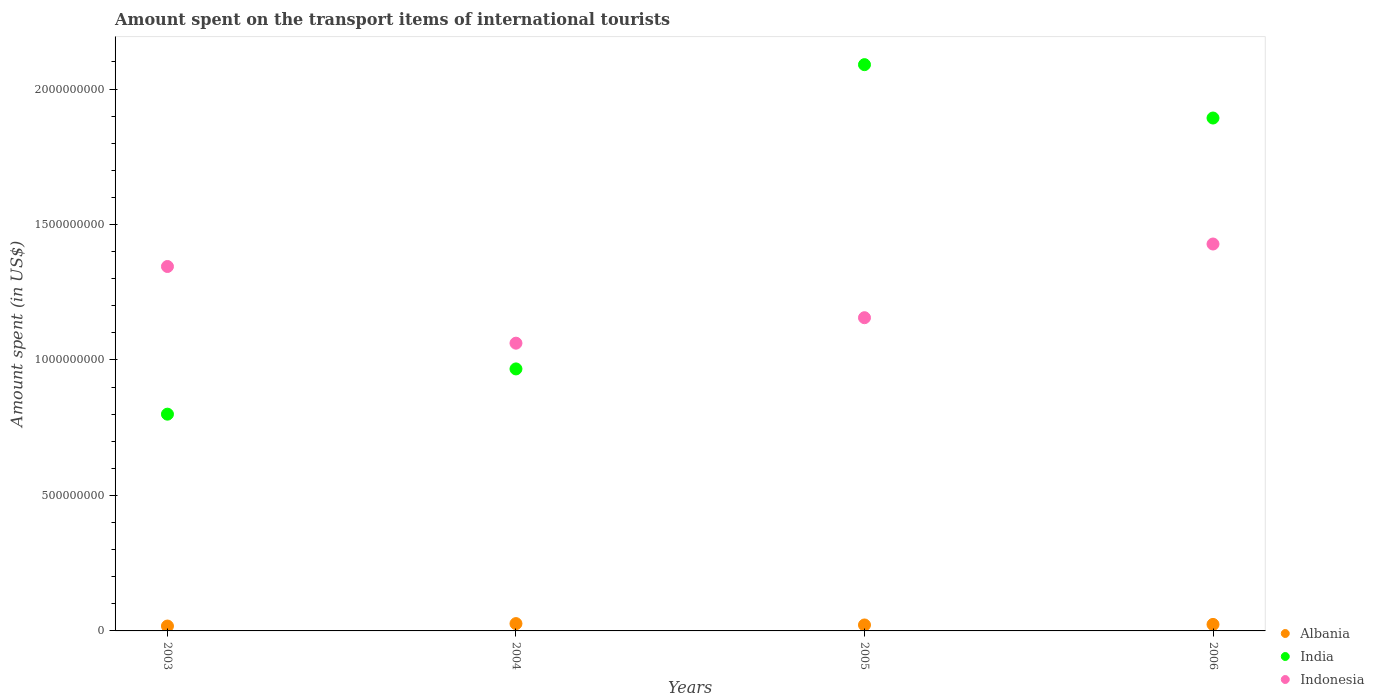How many different coloured dotlines are there?
Your response must be concise. 3. What is the amount spent on the transport items of international tourists in Indonesia in 2006?
Provide a succinct answer. 1.43e+09. Across all years, what is the maximum amount spent on the transport items of international tourists in India?
Provide a short and direct response. 2.09e+09. Across all years, what is the minimum amount spent on the transport items of international tourists in Albania?
Offer a terse response. 1.80e+07. In which year was the amount spent on the transport items of international tourists in Albania minimum?
Your answer should be very brief. 2003. What is the total amount spent on the transport items of international tourists in Indonesia in the graph?
Offer a very short reply. 4.99e+09. What is the difference between the amount spent on the transport items of international tourists in Albania in 2003 and that in 2004?
Your answer should be very brief. -9.00e+06. What is the difference between the amount spent on the transport items of international tourists in India in 2003 and the amount spent on the transport items of international tourists in Albania in 2005?
Ensure brevity in your answer.  7.78e+08. What is the average amount spent on the transport items of international tourists in Indonesia per year?
Your response must be concise. 1.25e+09. In the year 2003, what is the difference between the amount spent on the transport items of international tourists in Indonesia and amount spent on the transport items of international tourists in India?
Provide a succinct answer. 5.45e+08. What is the ratio of the amount spent on the transport items of international tourists in Albania in 2003 to that in 2006?
Offer a very short reply. 0.75. Is the amount spent on the transport items of international tourists in Indonesia in 2005 less than that in 2006?
Keep it short and to the point. Yes. What is the difference between the highest and the second highest amount spent on the transport items of international tourists in Indonesia?
Make the answer very short. 8.30e+07. What is the difference between the highest and the lowest amount spent on the transport items of international tourists in Indonesia?
Your answer should be compact. 3.66e+08. In how many years, is the amount spent on the transport items of international tourists in Albania greater than the average amount spent on the transport items of international tourists in Albania taken over all years?
Give a very brief answer. 2. Is the sum of the amount spent on the transport items of international tourists in India in 2003 and 2006 greater than the maximum amount spent on the transport items of international tourists in Albania across all years?
Provide a succinct answer. Yes. Is it the case that in every year, the sum of the amount spent on the transport items of international tourists in Albania and amount spent on the transport items of international tourists in India  is greater than the amount spent on the transport items of international tourists in Indonesia?
Provide a succinct answer. No. Does the amount spent on the transport items of international tourists in Albania monotonically increase over the years?
Keep it short and to the point. No. Is the amount spent on the transport items of international tourists in India strictly less than the amount spent on the transport items of international tourists in Albania over the years?
Offer a very short reply. No. Are the values on the major ticks of Y-axis written in scientific E-notation?
Your answer should be very brief. No. Does the graph contain grids?
Provide a short and direct response. No. Where does the legend appear in the graph?
Offer a very short reply. Bottom right. How many legend labels are there?
Make the answer very short. 3. What is the title of the graph?
Your response must be concise. Amount spent on the transport items of international tourists. What is the label or title of the X-axis?
Provide a short and direct response. Years. What is the label or title of the Y-axis?
Make the answer very short. Amount spent (in US$). What is the Amount spent (in US$) in Albania in 2003?
Offer a very short reply. 1.80e+07. What is the Amount spent (in US$) of India in 2003?
Offer a terse response. 8.00e+08. What is the Amount spent (in US$) in Indonesia in 2003?
Give a very brief answer. 1.34e+09. What is the Amount spent (in US$) in Albania in 2004?
Give a very brief answer. 2.70e+07. What is the Amount spent (in US$) in India in 2004?
Your response must be concise. 9.67e+08. What is the Amount spent (in US$) in Indonesia in 2004?
Offer a very short reply. 1.06e+09. What is the Amount spent (in US$) of Albania in 2005?
Provide a succinct answer. 2.20e+07. What is the Amount spent (in US$) in India in 2005?
Give a very brief answer. 2.09e+09. What is the Amount spent (in US$) of Indonesia in 2005?
Make the answer very short. 1.16e+09. What is the Amount spent (in US$) in Albania in 2006?
Ensure brevity in your answer.  2.40e+07. What is the Amount spent (in US$) of India in 2006?
Your answer should be very brief. 1.89e+09. What is the Amount spent (in US$) of Indonesia in 2006?
Provide a short and direct response. 1.43e+09. Across all years, what is the maximum Amount spent (in US$) in Albania?
Ensure brevity in your answer.  2.70e+07. Across all years, what is the maximum Amount spent (in US$) of India?
Make the answer very short. 2.09e+09. Across all years, what is the maximum Amount spent (in US$) of Indonesia?
Your answer should be compact. 1.43e+09. Across all years, what is the minimum Amount spent (in US$) of Albania?
Your response must be concise. 1.80e+07. Across all years, what is the minimum Amount spent (in US$) in India?
Keep it short and to the point. 8.00e+08. Across all years, what is the minimum Amount spent (in US$) of Indonesia?
Offer a very short reply. 1.06e+09. What is the total Amount spent (in US$) of Albania in the graph?
Your answer should be compact. 9.10e+07. What is the total Amount spent (in US$) of India in the graph?
Keep it short and to the point. 5.75e+09. What is the total Amount spent (in US$) of Indonesia in the graph?
Keep it short and to the point. 4.99e+09. What is the difference between the Amount spent (in US$) of Albania in 2003 and that in 2004?
Offer a very short reply. -9.00e+06. What is the difference between the Amount spent (in US$) in India in 2003 and that in 2004?
Provide a succinct answer. -1.67e+08. What is the difference between the Amount spent (in US$) in Indonesia in 2003 and that in 2004?
Provide a succinct answer. 2.83e+08. What is the difference between the Amount spent (in US$) in Albania in 2003 and that in 2005?
Keep it short and to the point. -4.00e+06. What is the difference between the Amount spent (in US$) in India in 2003 and that in 2005?
Your response must be concise. -1.29e+09. What is the difference between the Amount spent (in US$) of Indonesia in 2003 and that in 2005?
Offer a terse response. 1.89e+08. What is the difference between the Amount spent (in US$) in Albania in 2003 and that in 2006?
Provide a short and direct response. -6.00e+06. What is the difference between the Amount spent (in US$) of India in 2003 and that in 2006?
Provide a succinct answer. -1.09e+09. What is the difference between the Amount spent (in US$) in Indonesia in 2003 and that in 2006?
Provide a short and direct response. -8.30e+07. What is the difference between the Amount spent (in US$) of India in 2004 and that in 2005?
Provide a succinct answer. -1.12e+09. What is the difference between the Amount spent (in US$) in Indonesia in 2004 and that in 2005?
Make the answer very short. -9.40e+07. What is the difference between the Amount spent (in US$) of Albania in 2004 and that in 2006?
Ensure brevity in your answer.  3.00e+06. What is the difference between the Amount spent (in US$) of India in 2004 and that in 2006?
Give a very brief answer. -9.26e+08. What is the difference between the Amount spent (in US$) in Indonesia in 2004 and that in 2006?
Ensure brevity in your answer.  -3.66e+08. What is the difference between the Amount spent (in US$) in Albania in 2005 and that in 2006?
Offer a terse response. -2.00e+06. What is the difference between the Amount spent (in US$) of India in 2005 and that in 2006?
Offer a terse response. 1.97e+08. What is the difference between the Amount spent (in US$) of Indonesia in 2005 and that in 2006?
Make the answer very short. -2.72e+08. What is the difference between the Amount spent (in US$) of Albania in 2003 and the Amount spent (in US$) of India in 2004?
Offer a very short reply. -9.49e+08. What is the difference between the Amount spent (in US$) in Albania in 2003 and the Amount spent (in US$) in Indonesia in 2004?
Offer a very short reply. -1.04e+09. What is the difference between the Amount spent (in US$) in India in 2003 and the Amount spent (in US$) in Indonesia in 2004?
Make the answer very short. -2.62e+08. What is the difference between the Amount spent (in US$) in Albania in 2003 and the Amount spent (in US$) in India in 2005?
Provide a short and direct response. -2.07e+09. What is the difference between the Amount spent (in US$) of Albania in 2003 and the Amount spent (in US$) of Indonesia in 2005?
Ensure brevity in your answer.  -1.14e+09. What is the difference between the Amount spent (in US$) of India in 2003 and the Amount spent (in US$) of Indonesia in 2005?
Your answer should be very brief. -3.56e+08. What is the difference between the Amount spent (in US$) in Albania in 2003 and the Amount spent (in US$) in India in 2006?
Provide a succinct answer. -1.88e+09. What is the difference between the Amount spent (in US$) in Albania in 2003 and the Amount spent (in US$) in Indonesia in 2006?
Provide a short and direct response. -1.41e+09. What is the difference between the Amount spent (in US$) of India in 2003 and the Amount spent (in US$) of Indonesia in 2006?
Give a very brief answer. -6.28e+08. What is the difference between the Amount spent (in US$) in Albania in 2004 and the Amount spent (in US$) in India in 2005?
Ensure brevity in your answer.  -2.06e+09. What is the difference between the Amount spent (in US$) in Albania in 2004 and the Amount spent (in US$) in Indonesia in 2005?
Offer a very short reply. -1.13e+09. What is the difference between the Amount spent (in US$) in India in 2004 and the Amount spent (in US$) in Indonesia in 2005?
Your answer should be compact. -1.89e+08. What is the difference between the Amount spent (in US$) of Albania in 2004 and the Amount spent (in US$) of India in 2006?
Your response must be concise. -1.87e+09. What is the difference between the Amount spent (in US$) in Albania in 2004 and the Amount spent (in US$) in Indonesia in 2006?
Keep it short and to the point. -1.40e+09. What is the difference between the Amount spent (in US$) of India in 2004 and the Amount spent (in US$) of Indonesia in 2006?
Offer a terse response. -4.61e+08. What is the difference between the Amount spent (in US$) in Albania in 2005 and the Amount spent (in US$) in India in 2006?
Ensure brevity in your answer.  -1.87e+09. What is the difference between the Amount spent (in US$) in Albania in 2005 and the Amount spent (in US$) in Indonesia in 2006?
Offer a terse response. -1.41e+09. What is the difference between the Amount spent (in US$) in India in 2005 and the Amount spent (in US$) in Indonesia in 2006?
Offer a terse response. 6.62e+08. What is the average Amount spent (in US$) in Albania per year?
Provide a short and direct response. 2.28e+07. What is the average Amount spent (in US$) of India per year?
Offer a terse response. 1.44e+09. What is the average Amount spent (in US$) of Indonesia per year?
Provide a succinct answer. 1.25e+09. In the year 2003, what is the difference between the Amount spent (in US$) in Albania and Amount spent (in US$) in India?
Your response must be concise. -7.82e+08. In the year 2003, what is the difference between the Amount spent (in US$) in Albania and Amount spent (in US$) in Indonesia?
Keep it short and to the point. -1.33e+09. In the year 2003, what is the difference between the Amount spent (in US$) in India and Amount spent (in US$) in Indonesia?
Provide a short and direct response. -5.45e+08. In the year 2004, what is the difference between the Amount spent (in US$) of Albania and Amount spent (in US$) of India?
Offer a terse response. -9.40e+08. In the year 2004, what is the difference between the Amount spent (in US$) in Albania and Amount spent (in US$) in Indonesia?
Provide a succinct answer. -1.04e+09. In the year 2004, what is the difference between the Amount spent (in US$) of India and Amount spent (in US$) of Indonesia?
Give a very brief answer. -9.50e+07. In the year 2005, what is the difference between the Amount spent (in US$) in Albania and Amount spent (in US$) in India?
Give a very brief answer. -2.07e+09. In the year 2005, what is the difference between the Amount spent (in US$) in Albania and Amount spent (in US$) in Indonesia?
Give a very brief answer. -1.13e+09. In the year 2005, what is the difference between the Amount spent (in US$) in India and Amount spent (in US$) in Indonesia?
Offer a terse response. 9.34e+08. In the year 2006, what is the difference between the Amount spent (in US$) in Albania and Amount spent (in US$) in India?
Offer a very short reply. -1.87e+09. In the year 2006, what is the difference between the Amount spent (in US$) of Albania and Amount spent (in US$) of Indonesia?
Your answer should be very brief. -1.40e+09. In the year 2006, what is the difference between the Amount spent (in US$) in India and Amount spent (in US$) in Indonesia?
Your answer should be very brief. 4.65e+08. What is the ratio of the Amount spent (in US$) of Albania in 2003 to that in 2004?
Your response must be concise. 0.67. What is the ratio of the Amount spent (in US$) of India in 2003 to that in 2004?
Your response must be concise. 0.83. What is the ratio of the Amount spent (in US$) of Indonesia in 2003 to that in 2004?
Your answer should be compact. 1.27. What is the ratio of the Amount spent (in US$) in Albania in 2003 to that in 2005?
Provide a succinct answer. 0.82. What is the ratio of the Amount spent (in US$) of India in 2003 to that in 2005?
Give a very brief answer. 0.38. What is the ratio of the Amount spent (in US$) in Indonesia in 2003 to that in 2005?
Offer a terse response. 1.16. What is the ratio of the Amount spent (in US$) of Albania in 2003 to that in 2006?
Your answer should be very brief. 0.75. What is the ratio of the Amount spent (in US$) in India in 2003 to that in 2006?
Give a very brief answer. 0.42. What is the ratio of the Amount spent (in US$) in Indonesia in 2003 to that in 2006?
Offer a terse response. 0.94. What is the ratio of the Amount spent (in US$) of Albania in 2004 to that in 2005?
Your response must be concise. 1.23. What is the ratio of the Amount spent (in US$) in India in 2004 to that in 2005?
Ensure brevity in your answer.  0.46. What is the ratio of the Amount spent (in US$) in Indonesia in 2004 to that in 2005?
Offer a very short reply. 0.92. What is the ratio of the Amount spent (in US$) in Albania in 2004 to that in 2006?
Provide a succinct answer. 1.12. What is the ratio of the Amount spent (in US$) in India in 2004 to that in 2006?
Give a very brief answer. 0.51. What is the ratio of the Amount spent (in US$) of Indonesia in 2004 to that in 2006?
Your answer should be compact. 0.74. What is the ratio of the Amount spent (in US$) of Albania in 2005 to that in 2006?
Your answer should be very brief. 0.92. What is the ratio of the Amount spent (in US$) of India in 2005 to that in 2006?
Provide a short and direct response. 1.1. What is the ratio of the Amount spent (in US$) of Indonesia in 2005 to that in 2006?
Your answer should be very brief. 0.81. What is the difference between the highest and the second highest Amount spent (in US$) of India?
Provide a succinct answer. 1.97e+08. What is the difference between the highest and the second highest Amount spent (in US$) of Indonesia?
Give a very brief answer. 8.30e+07. What is the difference between the highest and the lowest Amount spent (in US$) of Albania?
Your answer should be compact. 9.00e+06. What is the difference between the highest and the lowest Amount spent (in US$) of India?
Offer a very short reply. 1.29e+09. What is the difference between the highest and the lowest Amount spent (in US$) in Indonesia?
Provide a short and direct response. 3.66e+08. 